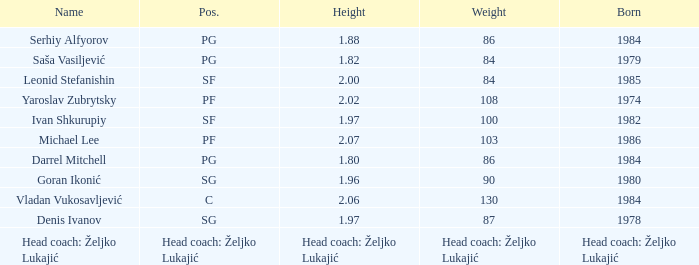What was the weightiness of serhiy alfyorov? 86.0. 